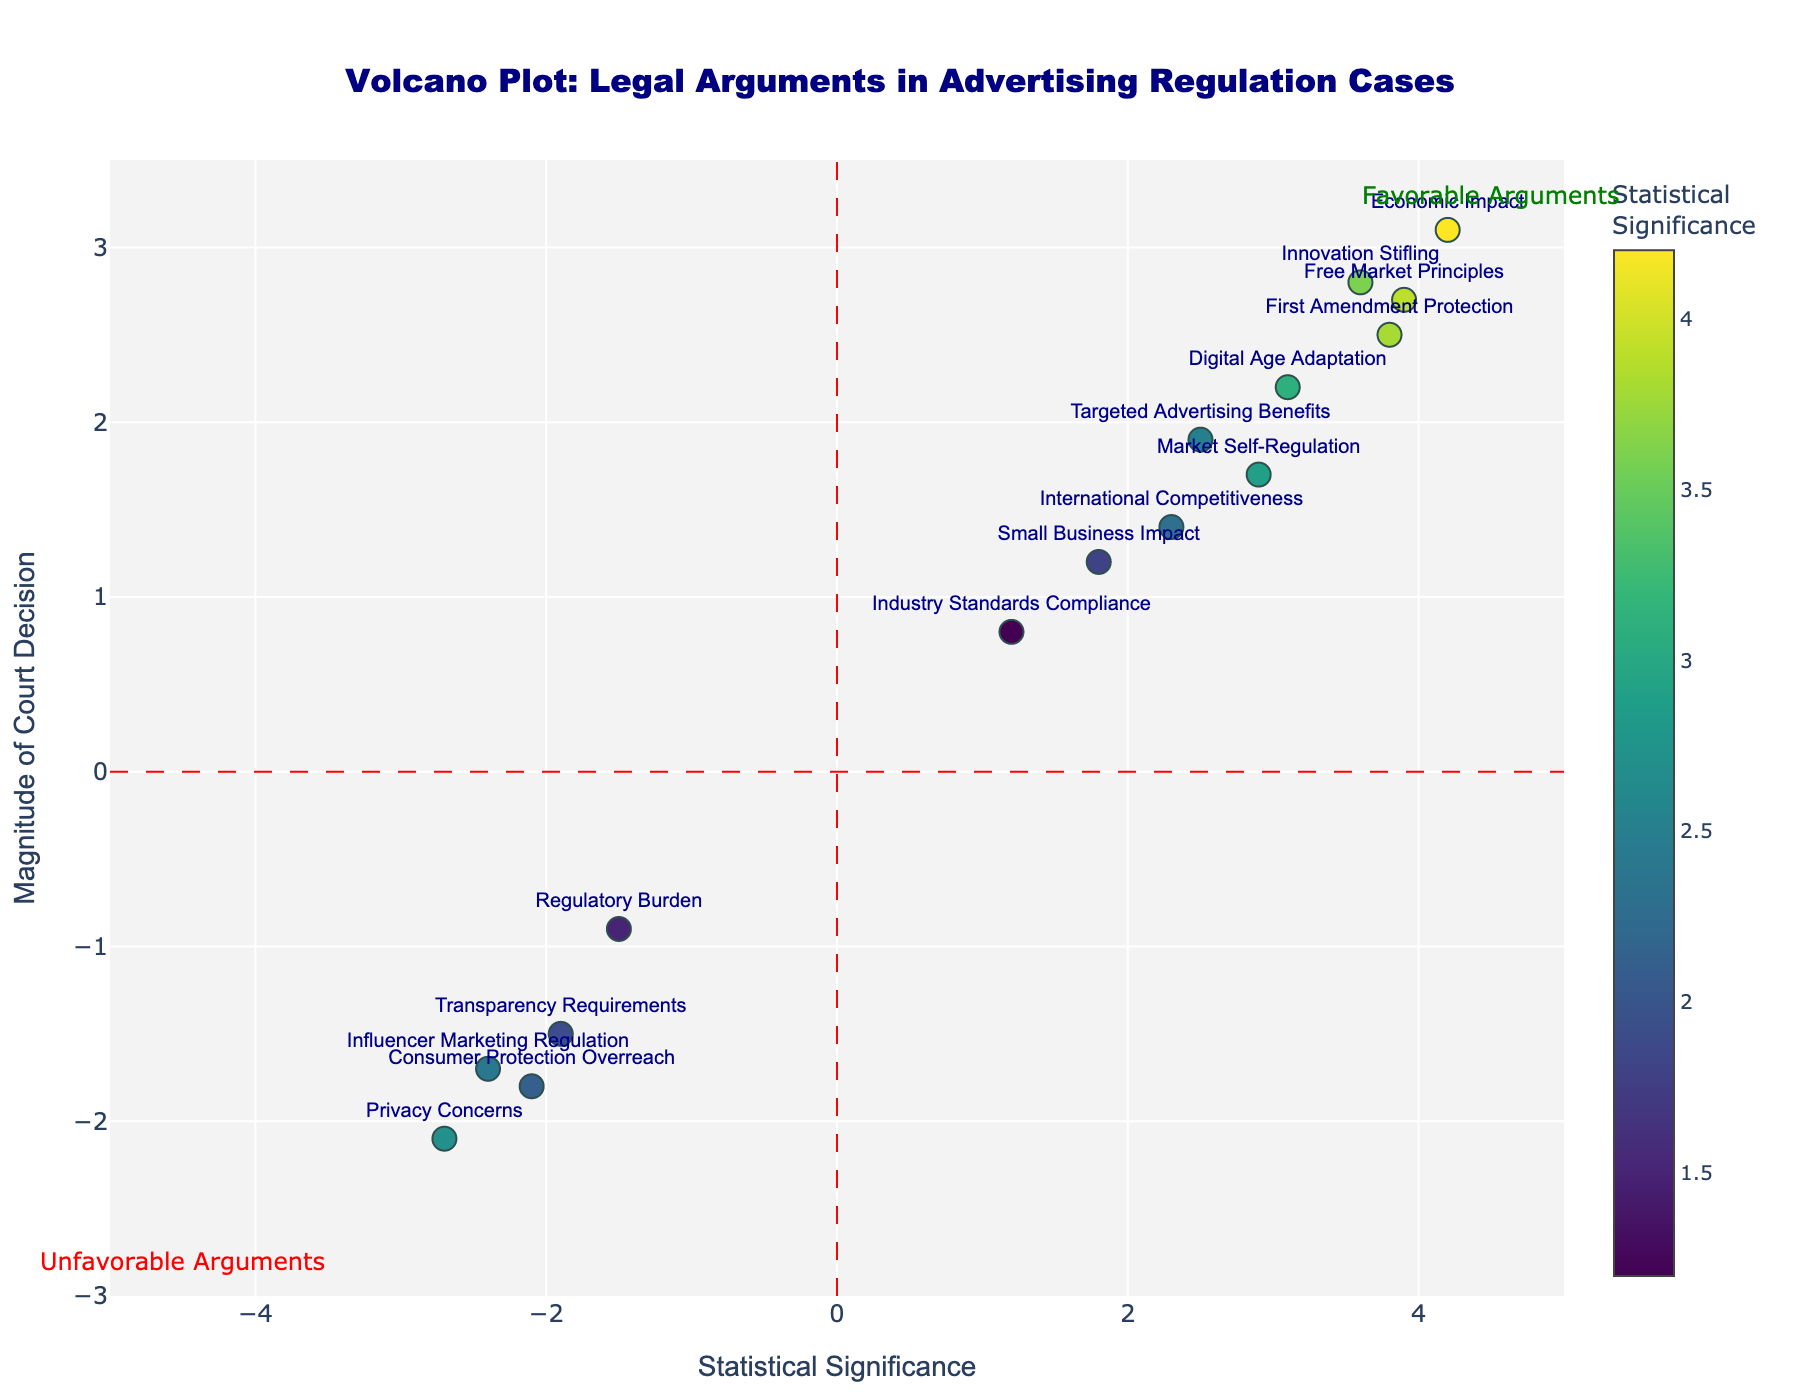What is the title of the plot? The title is displayed at the top of the plot. It reads "Volcano Plot: Legal Arguments in Advertising Regulation Cases".
Answer: Volcano Plot: Legal Arguments in Advertising Regulation Cases How many legal arguments show a positive magnitude of court decisions? Positive magnitudes are represented by points above the horizontal red line. Count these points. Arguments are: First Amendment Protection, Market Self-Regulation, Economic Impact, Innovation Stifling, International Competitiveness, Small Business Impact, Digital Age Adaptation, Targeted Advertising Benefits, and Free Market Principles, totaling 9 points.
Answer: 9 Which legal argument has the highest statistical significance and what is its magnitude of decision? Look for the data point furthest along the horizontal axis. 'Economic Impact' has the highest statistical significance of 4.2 and its magnitude is 3.1.
Answer: Economic Impact, 3.1 Which legal argument has the most negative magnitude of court decision? Look for the data point lowest on the vertical axis. 'Privacy Concerns' has the most negative magnitude at -2.1.
Answer: Privacy Concerns Compare the arguments 'First Amendment Protection' and 'Consumer Protection Overreach'. Which one has a greater magnitude of decision? Compare their magnitudes on the vertical axis. 'First Amendment Protection' is at 2.5, whereas 'Consumer Protection Overreach' is at -1.8.
Answer: First Amendment Protection What is the average magnitude of decision for arguments with statistical significance greater than 3? Identify relevant points: First Amendment Protection (2.5), Economic Impact (3.1), Innovation Stifling (2.8), Free Market Principles (2.7). Compute average: (2.5 + 3.1 + 2.8 + 2.7) / 4 = 2.78.
Answer: 2.78 How does the argument 'Innovinnovation Stifling' compare to 'Free Market Principles' in terms of statistical significance? Compare their positions along the horizontal axis. 'Innovation Stifling' has a statistical significance of 3.6 and 'Free Market Principles' has 3.9.
Answer: Free Market Principles is higher Which arguments are categorized as 'Unfavorable Arguments'? Observe the bottom left quadrant as marked by the annotation. Arguments: Consumer Protection Overreach, Regulatory Burden, Privacy Concerns, Transparency Requirements, Influencer Marketing Regulation.
Answer: Consumer Protection Overreach, Regulatory Burden, Privacy Concerns, Transparency Requirements, Influencer Marketing Regulation What is the total number of legal arguments represented in the plot? Count each data point plotted on the figure. There are a total of 15 points.
Answer: 15 